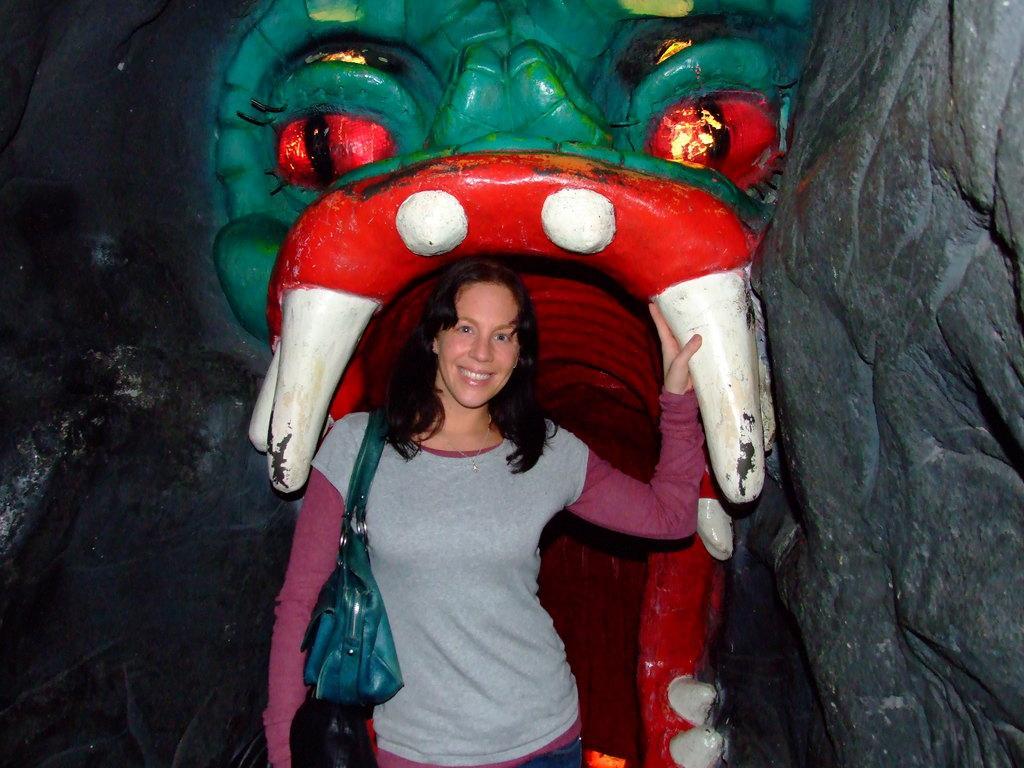Describe this image in one or two sentences. In this image I can see the person is standing and wearing the handbag. Back I can see the rock craving and it is painted with different color. 